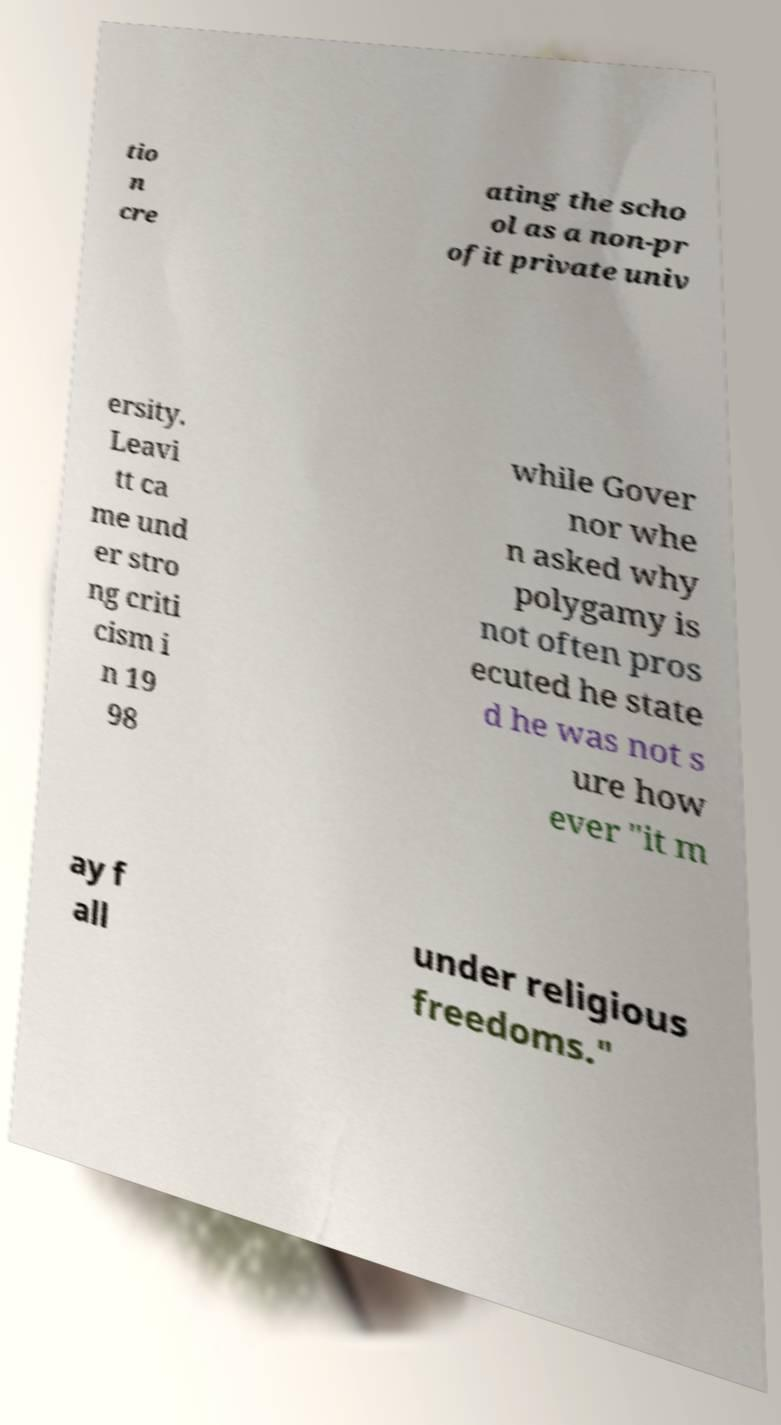Please read and relay the text visible in this image. What does it say? tio n cre ating the scho ol as a non-pr ofit private univ ersity. Leavi tt ca me und er stro ng criti cism i n 19 98 while Gover nor whe n asked why polygamy is not often pros ecuted he state d he was not s ure how ever "it m ay f all under religious freedoms." 